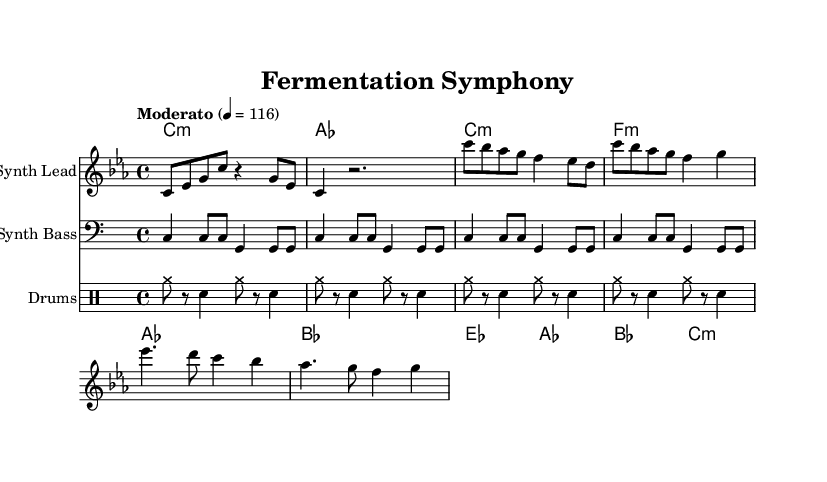What is the key signature of this music? The key signature is C minor, indicated by the presence of three flats (B-flat, E-flat, and A-flat) on the staff.
Answer: C minor What is the time signature of this music? The time signature is 4/4, which indicates that there are four beats in each measure and a quarter note receives one beat.
Answer: 4/4 What is the tempo marking of this piece? The tempo marking is "Moderato," which generally indicates a moderate tempo around 108 to 120 beats per minute. The exact marking is 4 = 116, specifying the tempo in beats per minute.
Answer: Moderato How many measures are in the intro section? The intro consists of 2 measures as indicated by the rhythm and note patterns in the corresponding section of the sheet music.
Answer: 2 What is the primary instrumental role of the "Synth Lead"? The "Synth Lead" carries the melody of the piece, which is evident as it includes the highest notes in the score that outline the main thematic material.
Answer: Melody In which section is the chord "C minor" first played? The "C minor" chord is first played in the intro section, as it is the first chord indicated in the harmonies.
Answer: Intro What type of musical patterns are used for the drum part? The drum part consists of simple rhythmic patterns, specifically categorized drum patterns that include cymbals and snare hits, generating a rhythmic backdrop.
Answer: Drum patterns 